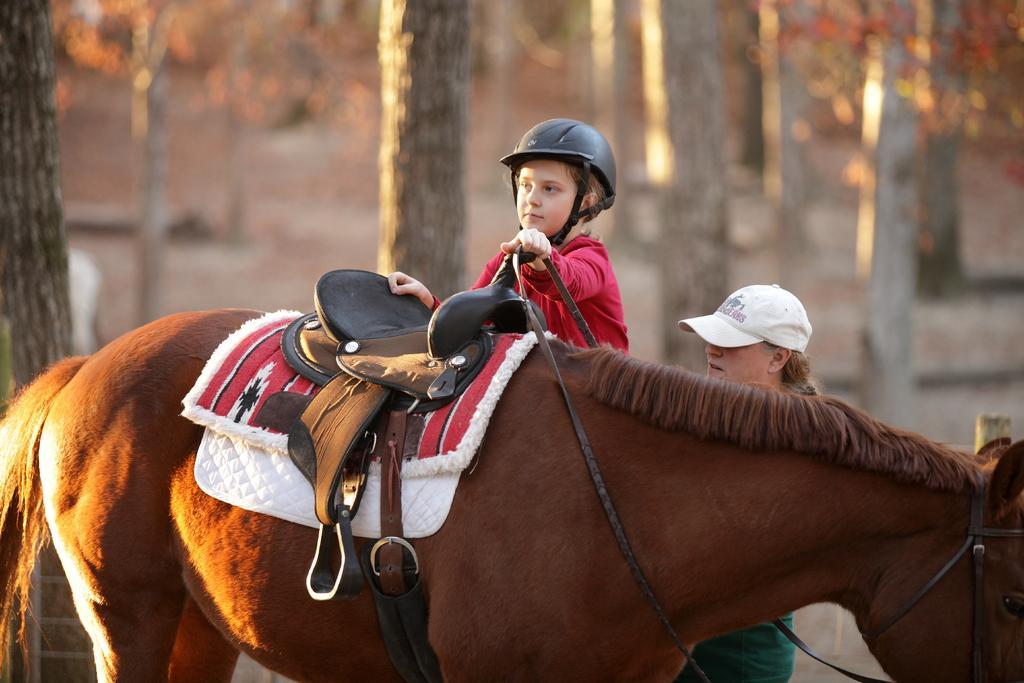Please provide a concise description of this image. In this image there is a horse at the back there are two persons one person is holding the horse belt,at the back ground there are some trees. 